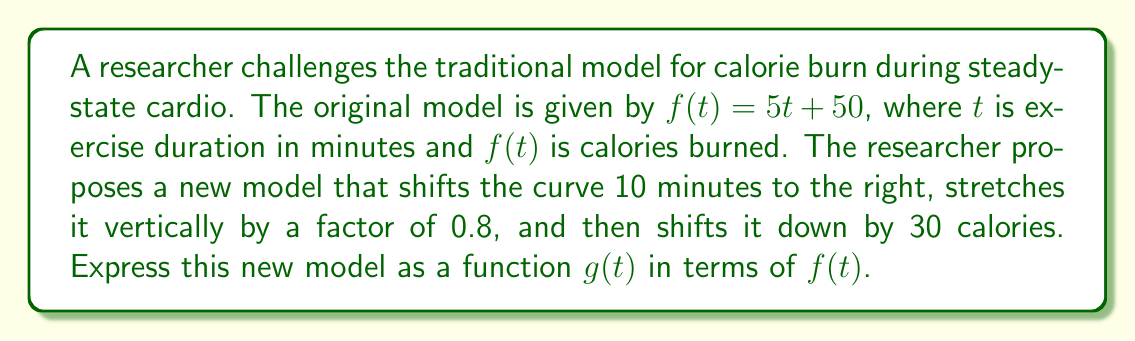Teach me how to tackle this problem. Let's apply the transformations step-by-step:

1. Shift 10 minutes to the right: Replace $t$ with $(t - 10)$
   $f(t - 10)$

2. Stretch vertically by a factor of 0.8:
   $0.8f(t - 10)$

3. Shift down by 30 calories:
   $0.8f(t - 10) - 30$

Therefore, the new function $g(t)$ can be expressed as:

$$g(t) = 0.8f(t - 10) - 30$$

This composition of transformations models the researcher's proposed relationship between exercise duration and calorie burn, challenging the traditional physiologist's model.
Answer: $g(t) = 0.8f(t - 10) - 30$ 